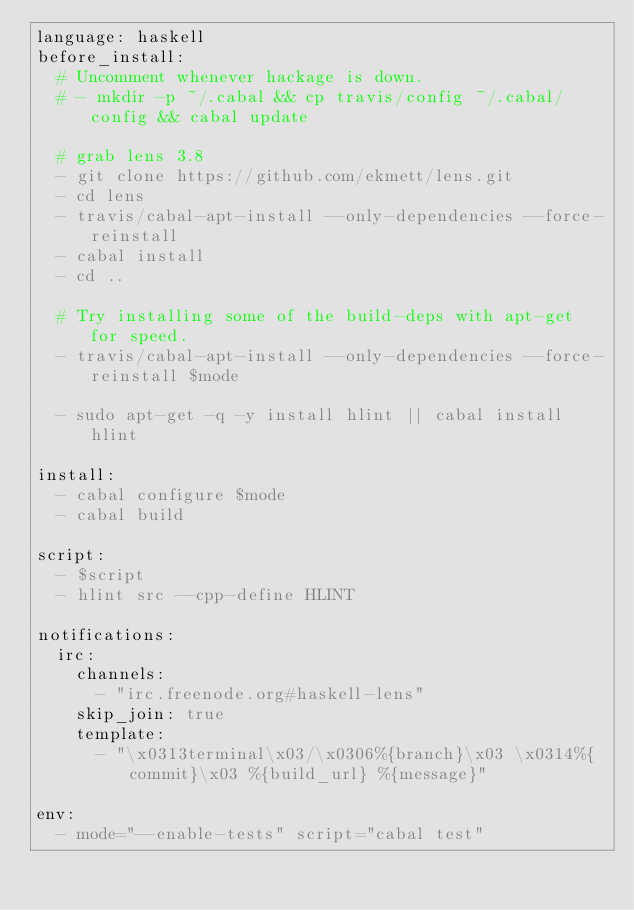<code> <loc_0><loc_0><loc_500><loc_500><_YAML_>language: haskell
before_install:
  # Uncomment whenever hackage is down.
  # - mkdir -p ~/.cabal && cp travis/config ~/.cabal/config && cabal update

  # grab lens 3.8
  - git clone https://github.com/ekmett/lens.git
  - cd lens
  - travis/cabal-apt-install --only-dependencies --force-reinstall
  - cabal install
  - cd ..

  # Try installing some of the build-deps with apt-get for speed.
  - travis/cabal-apt-install --only-dependencies --force-reinstall $mode

  - sudo apt-get -q -y install hlint || cabal install hlint

install:
  - cabal configure $mode
  - cabal build

script:
  - $script
  - hlint src --cpp-define HLINT

notifications:
  irc:
    channels:
      - "irc.freenode.org#haskell-lens"
    skip_join: true
    template:
      - "\x0313terminal\x03/\x0306%{branch}\x03 \x0314%{commit}\x03 %{build_url} %{message}"

env:
  - mode="--enable-tests" script="cabal test"
</code> 